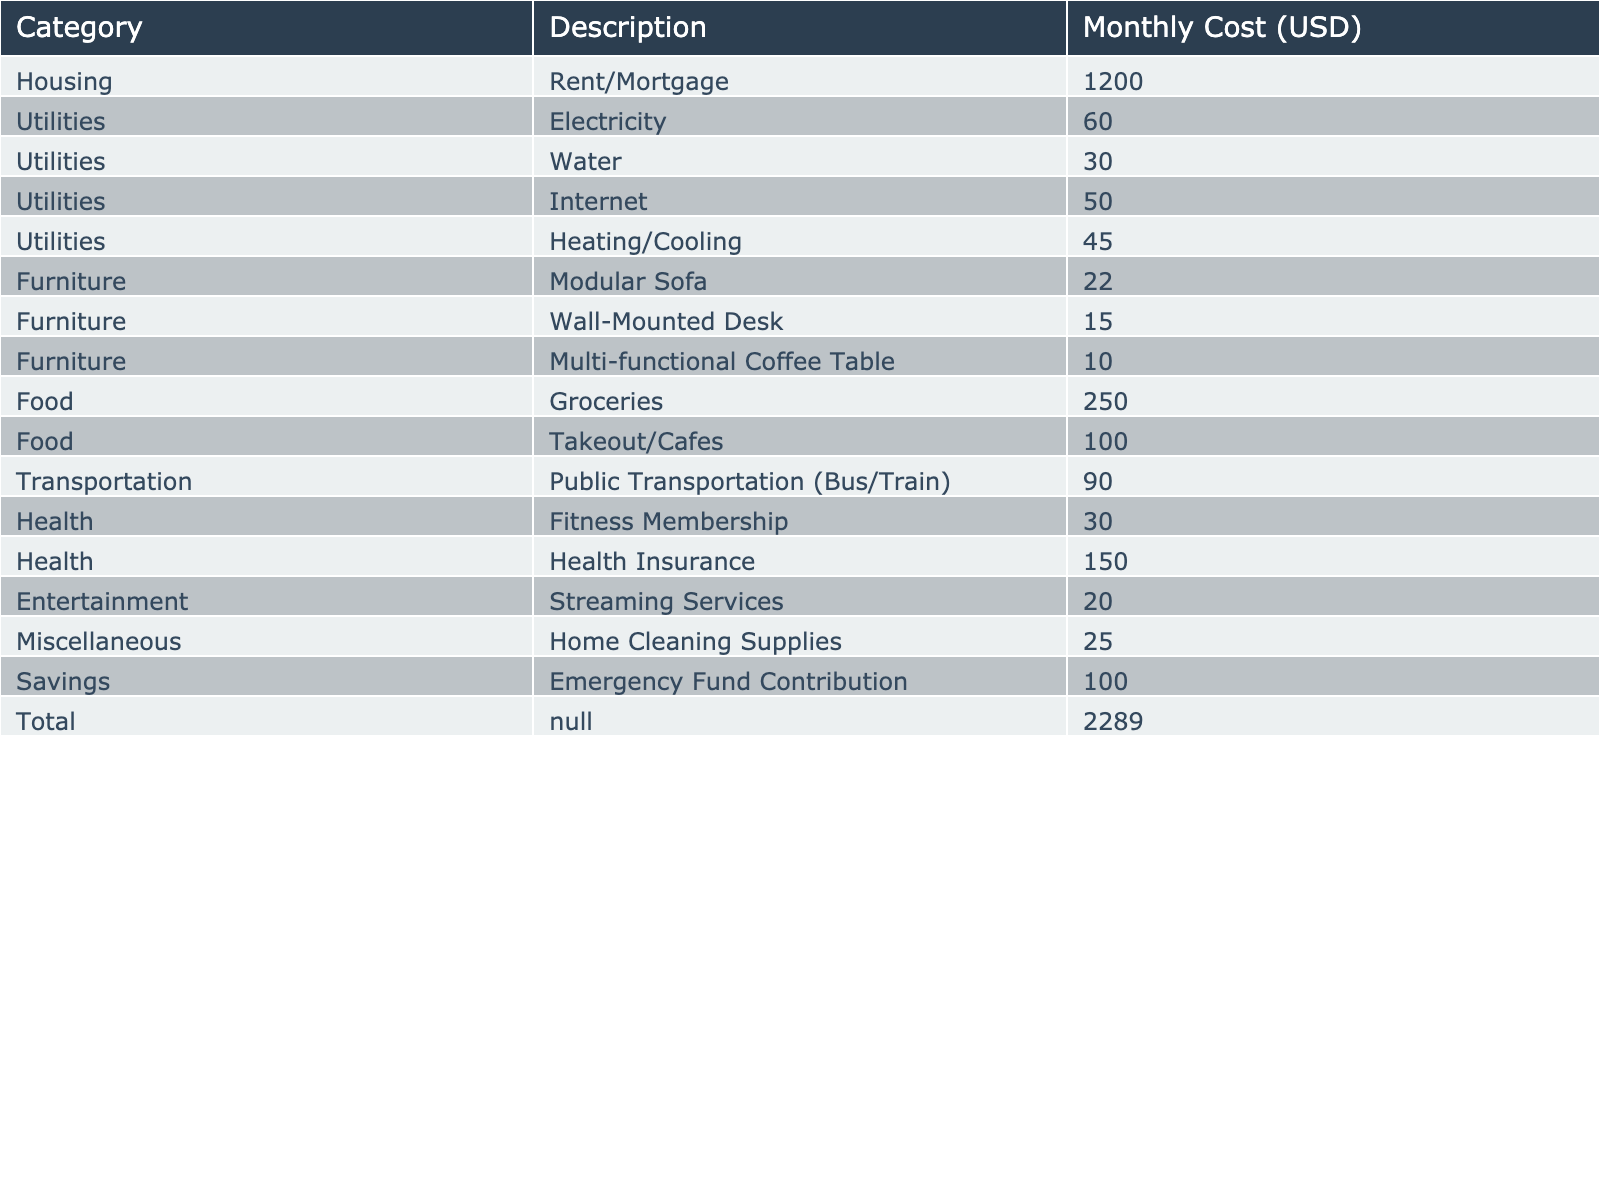What is the total monthly cost for utilities? The utilities include electricity (60), water (30), internet (50), and heating/cooling (45). By adding these values together, we get 60 + 30 + 50 + 45 = 185.
Answer: 185 How much is spent on food each month? The food category includes groceries (250) and takeout/cafes (100). Adding these amounts, we find 250 + 100 = 350.
Answer: 350 Is the monthly cost of a modular sofa higher than that of a wall-mounted desk? The cost of the modular sofa is 22 and the wall-mounted desk is 15. Since 22 > 15, the statement is true.
Answer: Yes What is the total monthly expenditure on health-related expenses? Health-related costs include fitness membership (30) and health insurance (150). Summing these gives us 30 + 150 = 180.
Answer: 180 What is the average monthly transportation cost? The only transportation cost provided is for public transportation, which is 90. Since there is only one value, the average is 90 itself.
Answer: 90 Is the contribution to the emergency fund higher than the total cost of the modular sofa and the wall-mounted desk combined? The emergency fund contribution is 100. The cost of the modular sofa (22) and wall-mounted desk (15) combined is 22 + 15 = 37. Since 100 > 37, the statement is true.
Answer: Yes How much more is spent on entertainment compared to the cost of home cleaning supplies? The entertainment cost is 20, while home cleaning supplies cost 25. To find the difference: 20 - 25 = -5, meaning entertainment costs are less.
Answer: -5 What percentage of the total budget is allocated to food? The total monthly budget is 2289 and the food cost is 350. The percentage is (350 / 2289) * 100, which is approximately 15.3%.
Answer: 15.3% What are the total costs for housing versus miscellaneous expenses? Housing costs 1200, while miscellaneous expenses total 25. Subtracting we get: 1200 - 25 = 1175 indicating housing costs significantly more.
Answer: 1175 